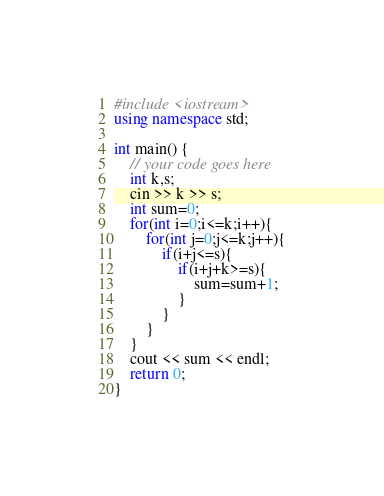<code> <loc_0><loc_0><loc_500><loc_500><_C++_>#include <iostream>
using namespace std;

int main() {
	// your code goes here
	int k,s;
	cin >> k >> s;
	int sum=0;
	for(int i=0;i<=k;i++){
		for(int j=0;j<=k;j++){
			if(i+j<=s){
				if(i+j+k>=s){
					sum=sum+1;
				}	
			}
		}
	}
	cout << sum << endl;
	return 0;
}</code> 